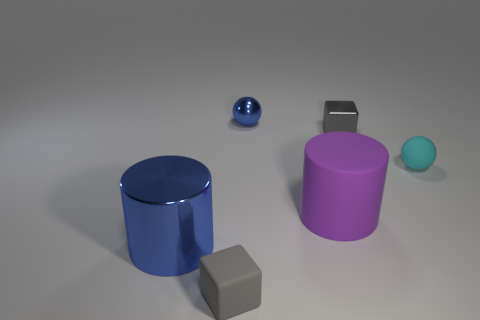Add 2 tiny blocks. How many objects exist? 8 Subtract 2 cubes. How many cubes are left? 0 Subtract all spheres. How many objects are left? 4 Subtract all cyan cylinders. Subtract all cyan cubes. How many cylinders are left? 2 Subtract all blue spheres. How many gray cylinders are left? 0 Subtract all blue metal balls. Subtract all shiny cylinders. How many objects are left? 4 Add 3 small gray metal objects. How many small gray metal objects are left? 4 Add 1 large cylinders. How many large cylinders exist? 3 Subtract 0 yellow cubes. How many objects are left? 6 